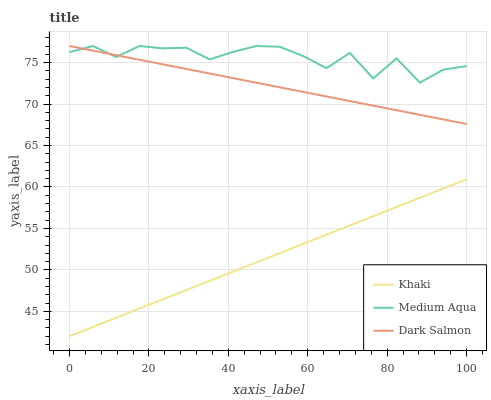Does Khaki have the minimum area under the curve?
Answer yes or no. Yes. Does Medium Aqua have the maximum area under the curve?
Answer yes or no. Yes. Does Dark Salmon have the minimum area under the curve?
Answer yes or no. No. Does Dark Salmon have the maximum area under the curve?
Answer yes or no. No. Is Dark Salmon the smoothest?
Answer yes or no. Yes. Is Medium Aqua the roughest?
Answer yes or no. Yes. Is Medium Aqua the smoothest?
Answer yes or no. No. Is Dark Salmon the roughest?
Answer yes or no. No. Does Khaki have the lowest value?
Answer yes or no. Yes. Does Dark Salmon have the lowest value?
Answer yes or no. No. Does Dark Salmon have the highest value?
Answer yes or no. Yes. Is Khaki less than Medium Aqua?
Answer yes or no. Yes. Is Dark Salmon greater than Khaki?
Answer yes or no. Yes. Does Medium Aqua intersect Dark Salmon?
Answer yes or no. Yes. Is Medium Aqua less than Dark Salmon?
Answer yes or no. No. Is Medium Aqua greater than Dark Salmon?
Answer yes or no. No. Does Khaki intersect Medium Aqua?
Answer yes or no. No. 